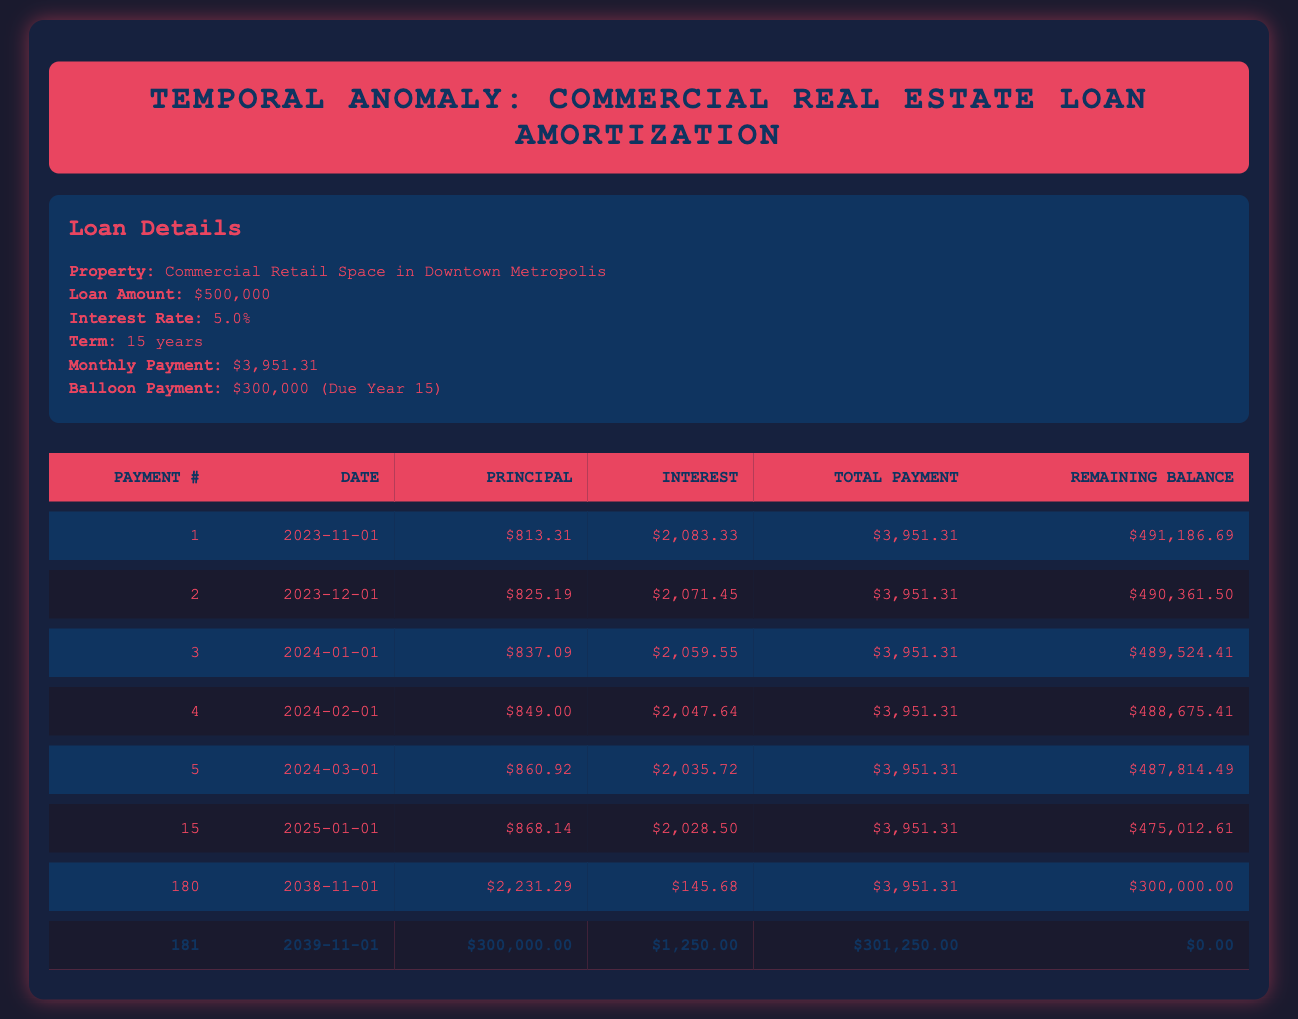What is the total payment amount for the first month? The total payment amount for the first month is provided in the table under the "Total Payment" column for the first payment entry. It states the total payment as $3,951.31.
Answer: 3951.31 What is the remaining balance after the 15th payment? The remaining balance after the 15th payment can be found in the table under the "Remaining Balance" for the entry of the 15th payment. It is stated as $475,012.61.
Answer: 475012.61 Is the balloon payment due in the 15th year? The loan details specify that the balloon payment is due in year 15, which confirms that the statement is true.
Answer: Yes How much was paid towards principal in the 3rd payment? The principal payment for the 3rd payment entry in the table is listed under the "Principal" column for that payment, which states it as $837.09.
Answer: 837.09 What is the average monthly payment over the entire loan period? The monthly payment amount is constant at $3,951.31 for each month. Since there are a total of 180 payments (15 years), forming an average would simply return the same amount: $3,951.31.
Answer: 3951.31 How much will be the total payment in the last month? The total payment in the last month can be found in the entry for the 181st payment. It states that the total payment is $301,250.00 for that payment entry.
Answer: 301250.00 How much total interest is paid in the first five payments? To find the total interest paid in the first five payments, add the interest payments from the first five payment entries: $2083.33 + $2071.45 + $2059.55 + $2047.64 + $2035.72 = $10,397.69.
Answer: 10397.69 What is the largest principal payment made during the loan? The largest principal payment can be identified by reviewing the "Principal" column in the table and noticing that the largest value is found in the 181st payment, which is $300,000.00.
Answer: 300000.00 How does the interest payment change over the first year? By analyzing the "Interest" column for each month in the first year, we notice that it decreases steadily from $2,083.33 in the first payment to $2,028.50 in the 15th payment. This indicates a decreasing trend in interest payments over the year, generally due to reduced remaining balance.
Answer: Decreases steadily 